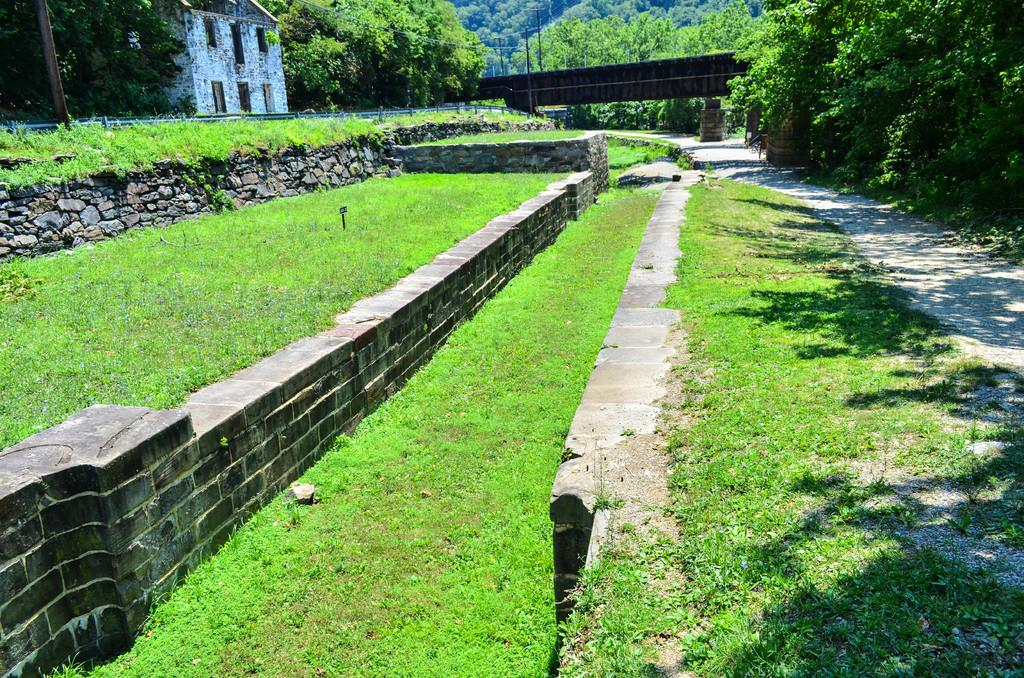What type of landscape is depicted in the image? There is a grassland in the image. What structure can be seen in the middle of the grassland? There is a wall in the middle of the grassland. What is located beside the wall? There is a road beside the wall. What type of vegetation is present in the image? There are trees in the image. What type of man-made structure can be seen in the image? There is a building in the image. What type of bait is being used to catch fish in the image? There is no fishing or bait present in the image; it features a grassland, wall, road, trees, and a building. Where is the camp located in the image? There is no camp present in the image; it features a grassland, wall, road, trees, and a building. 